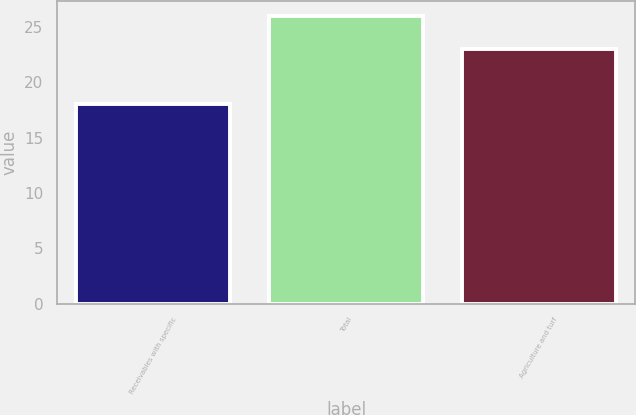Convert chart. <chart><loc_0><loc_0><loc_500><loc_500><bar_chart><fcel>Receivables with specific<fcel>Total<fcel>Agriculture and turf<nl><fcel>18<fcel>26<fcel>23<nl></chart> 